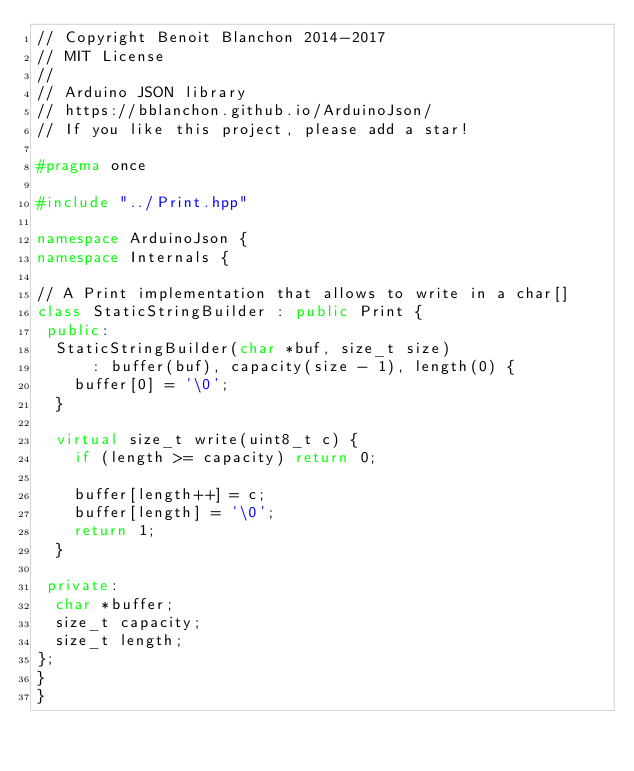Convert code to text. <code><loc_0><loc_0><loc_500><loc_500><_C++_>// Copyright Benoit Blanchon 2014-2017
// MIT License
//
// Arduino JSON library
// https://bblanchon.github.io/ArduinoJson/
// If you like this project, please add a star!

#pragma once

#include "../Print.hpp"

namespace ArduinoJson {
namespace Internals {

// A Print implementation that allows to write in a char[]
class StaticStringBuilder : public Print {
 public:
  StaticStringBuilder(char *buf, size_t size)
      : buffer(buf), capacity(size - 1), length(0) {
    buffer[0] = '\0';
  }

  virtual size_t write(uint8_t c) {
    if (length >= capacity) return 0;

    buffer[length++] = c;
    buffer[length] = '\0';
    return 1;
  }

 private:
  char *buffer;
  size_t capacity;
  size_t length;
};
}
}
</code> 